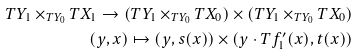<formula> <loc_0><loc_0><loc_500><loc_500>T Y _ { 1 } \times _ { T Y _ { 0 } } T X _ { 1 } \to ( T Y _ { 1 } \times _ { T Y _ { 0 } } T X _ { 0 } ) \times ( T Y _ { 1 } \times _ { T Y _ { 0 } } T X _ { 0 } ) \\ ( y , x ) \mapsto ( y , s ( x ) ) \times ( y \cdot T f ^ { \prime } _ { 1 } ( x ) , t ( x ) )</formula> 